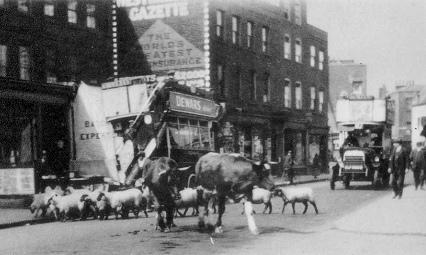What is in front of the vehicle?

Choices:
A) animals
B) traffic cones
C) eggs
D) balloons animals 